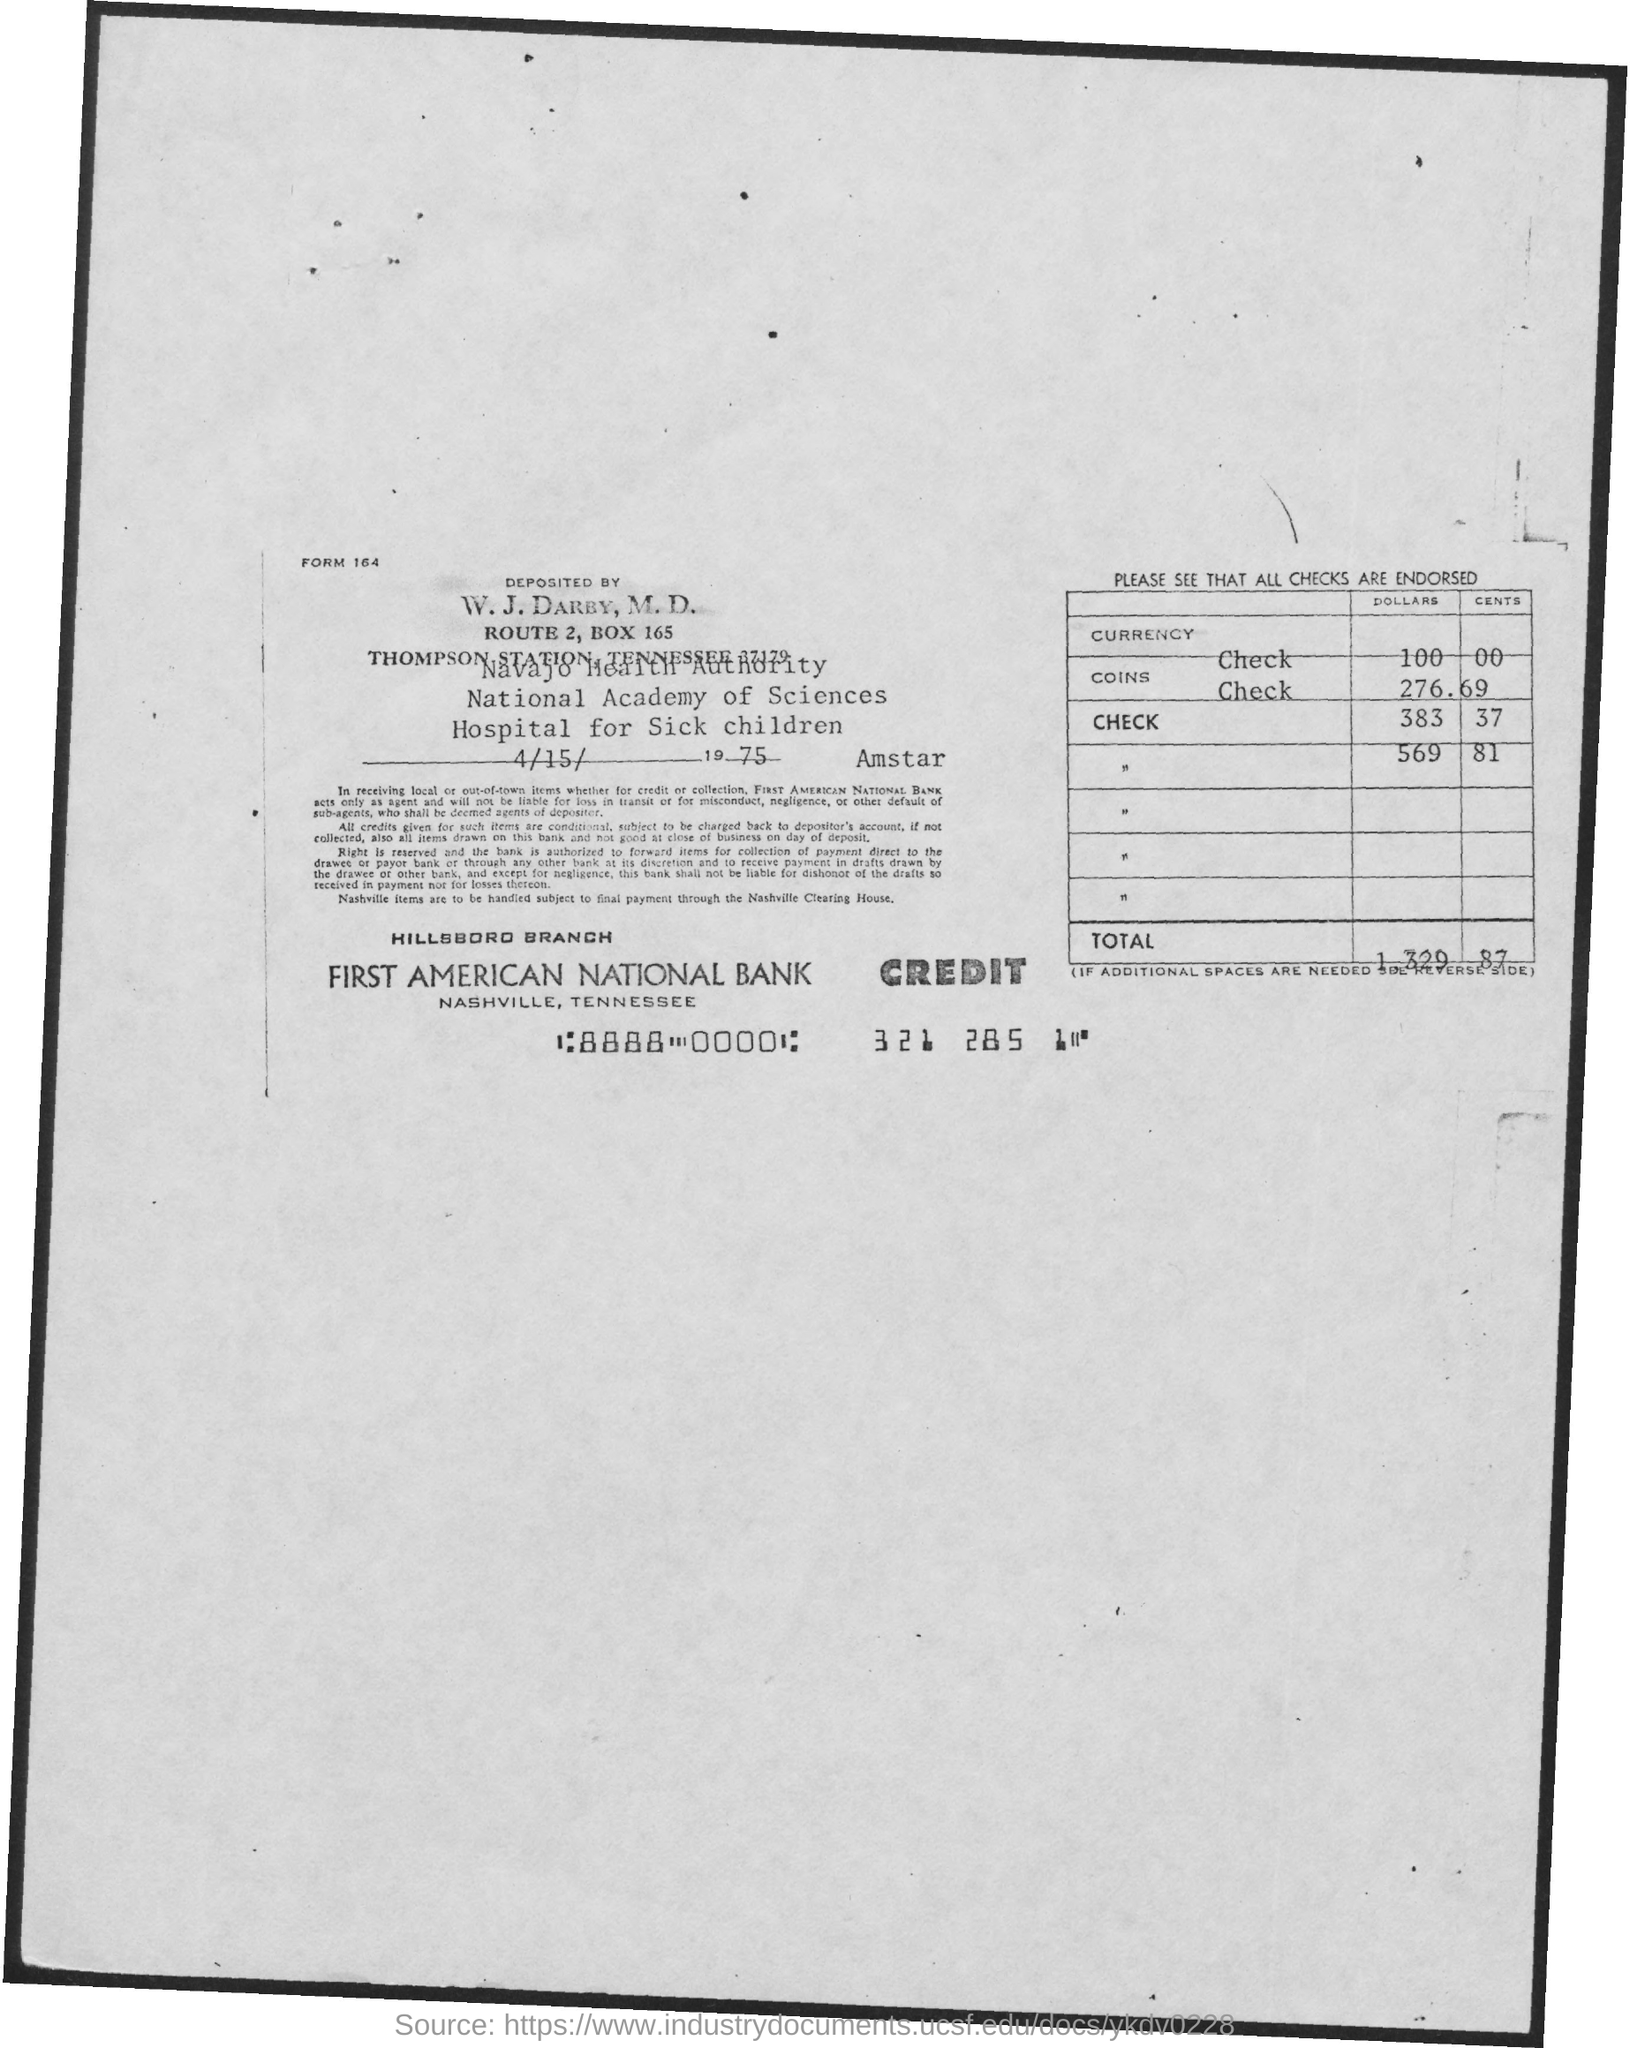Identify some key points in this picture. The name of the bank is First American National Bank. The address of First American National Bank is located in Nashville, Tennessee. The form number is 164... The total amount is $1,329.87, including any decimal points and commas. The date of deposit is April 15, 1975. 